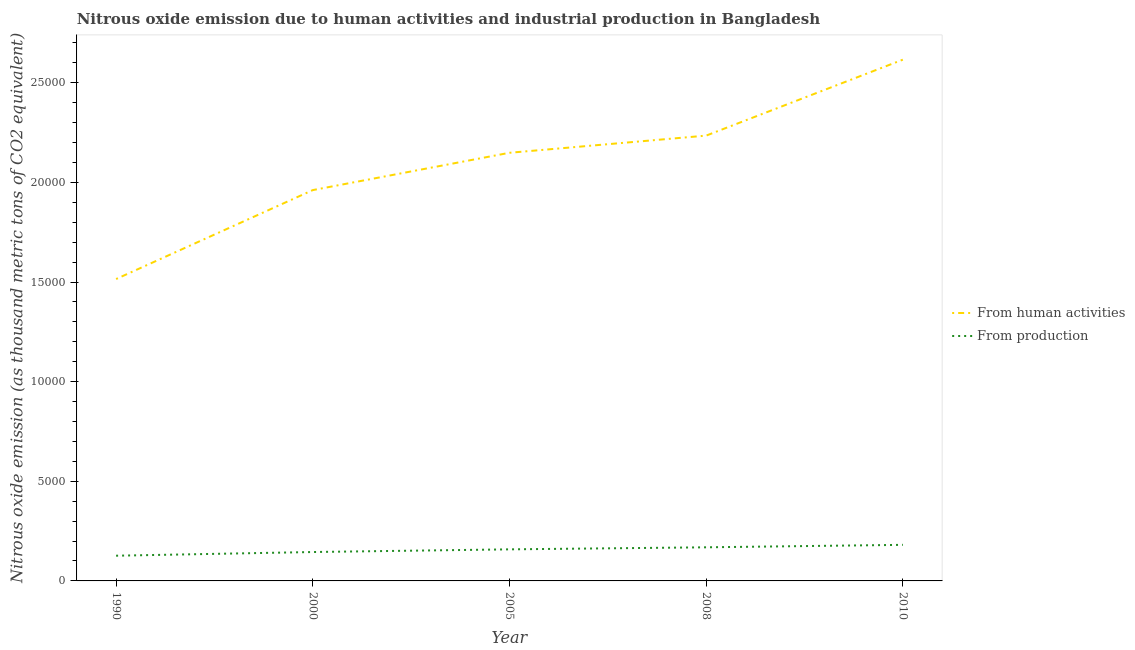Is the number of lines equal to the number of legend labels?
Provide a short and direct response. Yes. What is the amount of emissions from human activities in 2005?
Keep it short and to the point. 2.15e+04. Across all years, what is the maximum amount of emissions from human activities?
Your answer should be very brief. 2.62e+04. Across all years, what is the minimum amount of emissions generated from industries?
Offer a very short reply. 1265.7. In which year was the amount of emissions generated from industries maximum?
Provide a short and direct response. 2010. In which year was the amount of emissions generated from industries minimum?
Your answer should be compact. 1990. What is the total amount of emissions from human activities in the graph?
Offer a very short reply. 1.05e+05. What is the difference between the amount of emissions generated from industries in 2008 and that in 2010?
Your answer should be compact. -123.9. What is the difference between the amount of emissions generated from industries in 2008 and the amount of emissions from human activities in 2000?
Your answer should be compact. -1.79e+04. What is the average amount of emissions from human activities per year?
Your answer should be compact. 2.10e+04. In the year 2000, what is the difference between the amount of emissions from human activities and amount of emissions generated from industries?
Offer a very short reply. 1.82e+04. In how many years, is the amount of emissions generated from industries greater than 4000 thousand metric tons?
Your response must be concise. 0. What is the ratio of the amount of emissions generated from industries in 1990 to that in 2008?
Keep it short and to the point. 0.75. Is the amount of emissions generated from industries in 2000 less than that in 2010?
Provide a short and direct response. Yes. Is the difference between the amount of emissions from human activities in 2000 and 2008 greater than the difference between the amount of emissions generated from industries in 2000 and 2008?
Provide a short and direct response. No. What is the difference between the highest and the second highest amount of emissions from human activities?
Your response must be concise. 3811.2. What is the difference between the highest and the lowest amount of emissions generated from industries?
Provide a short and direct response. 545.1. Is the sum of the amount of emissions generated from industries in 1990 and 2010 greater than the maximum amount of emissions from human activities across all years?
Your response must be concise. No. Does the amount of emissions generated from industries monotonically increase over the years?
Your response must be concise. Yes. Is the amount of emissions from human activities strictly greater than the amount of emissions generated from industries over the years?
Your answer should be compact. Yes. Is the amount of emissions generated from industries strictly less than the amount of emissions from human activities over the years?
Offer a terse response. Yes. Does the graph contain grids?
Ensure brevity in your answer.  No. Where does the legend appear in the graph?
Keep it short and to the point. Center right. What is the title of the graph?
Your response must be concise. Nitrous oxide emission due to human activities and industrial production in Bangladesh. What is the label or title of the Y-axis?
Give a very brief answer. Nitrous oxide emission (as thousand metric tons of CO2 equivalent). What is the Nitrous oxide emission (as thousand metric tons of CO2 equivalent) of From human activities in 1990?
Provide a short and direct response. 1.52e+04. What is the Nitrous oxide emission (as thousand metric tons of CO2 equivalent) in From production in 1990?
Provide a short and direct response. 1265.7. What is the Nitrous oxide emission (as thousand metric tons of CO2 equivalent) in From human activities in 2000?
Provide a succinct answer. 1.96e+04. What is the Nitrous oxide emission (as thousand metric tons of CO2 equivalent) of From production in 2000?
Give a very brief answer. 1450.3. What is the Nitrous oxide emission (as thousand metric tons of CO2 equivalent) of From human activities in 2005?
Provide a succinct answer. 2.15e+04. What is the Nitrous oxide emission (as thousand metric tons of CO2 equivalent) in From production in 2005?
Offer a very short reply. 1584.6. What is the Nitrous oxide emission (as thousand metric tons of CO2 equivalent) in From human activities in 2008?
Your response must be concise. 2.23e+04. What is the Nitrous oxide emission (as thousand metric tons of CO2 equivalent) in From production in 2008?
Offer a terse response. 1686.9. What is the Nitrous oxide emission (as thousand metric tons of CO2 equivalent) in From human activities in 2010?
Give a very brief answer. 2.62e+04. What is the Nitrous oxide emission (as thousand metric tons of CO2 equivalent) of From production in 2010?
Make the answer very short. 1810.8. Across all years, what is the maximum Nitrous oxide emission (as thousand metric tons of CO2 equivalent) in From human activities?
Your response must be concise. 2.62e+04. Across all years, what is the maximum Nitrous oxide emission (as thousand metric tons of CO2 equivalent) in From production?
Your answer should be very brief. 1810.8. Across all years, what is the minimum Nitrous oxide emission (as thousand metric tons of CO2 equivalent) in From human activities?
Your answer should be compact. 1.52e+04. Across all years, what is the minimum Nitrous oxide emission (as thousand metric tons of CO2 equivalent) in From production?
Provide a short and direct response. 1265.7. What is the total Nitrous oxide emission (as thousand metric tons of CO2 equivalent) of From human activities in the graph?
Offer a terse response. 1.05e+05. What is the total Nitrous oxide emission (as thousand metric tons of CO2 equivalent) of From production in the graph?
Provide a succinct answer. 7798.3. What is the difference between the Nitrous oxide emission (as thousand metric tons of CO2 equivalent) in From human activities in 1990 and that in 2000?
Ensure brevity in your answer.  -4463.6. What is the difference between the Nitrous oxide emission (as thousand metric tons of CO2 equivalent) of From production in 1990 and that in 2000?
Make the answer very short. -184.6. What is the difference between the Nitrous oxide emission (as thousand metric tons of CO2 equivalent) of From human activities in 1990 and that in 2005?
Provide a short and direct response. -6336.1. What is the difference between the Nitrous oxide emission (as thousand metric tons of CO2 equivalent) of From production in 1990 and that in 2005?
Make the answer very short. -318.9. What is the difference between the Nitrous oxide emission (as thousand metric tons of CO2 equivalent) of From human activities in 1990 and that in 2008?
Offer a very short reply. -7197.8. What is the difference between the Nitrous oxide emission (as thousand metric tons of CO2 equivalent) in From production in 1990 and that in 2008?
Your answer should be compact. -421.2. What is the difference between the Nitrous oxide emission (as thousand metric tons of CO2 equivalent) in From human activities in 1990 and that in 2010?
Offer a terse response. -1.10e+04. What is the difference between the Nitrous oxide emission (as thousand metric tons of CO2 equivalent) in From production in 1990 and that in 2010?
Ensure brevity in your answer.  -545.1. What is the difference between the Nitrous oxide emission (as thousand metric tons of CO2 equivalent) of From human activities in 2000 and that in 2005?
Make the answer very short. -1872.5. What is the difference between the Nitrous oxide emission (as thousand metric tons of CO2 equivalent) in From production in 2000 and that in 2005?
Offer a very short reply. -134.3. What is the difference between the Nitrous oxide emission (as thousand metric tons of CO2 equivalent) in From human activities in 2000 and that in 2008?
Make the answer very short. -2734.2. What is the difference between the Nitrous oxide emission (as thousand metric tons of CO2 equivalent) of From production in 2000 and that in 2008?
Give a very brief answer. -236.6. What is the difference between the Nitrous oxide emission (as thousand metric tons of CO2 equivalent) of From human activities in 2000 and that in 2010?
Offer a very short reply. -6545.4. What is the difference between the Nitrous oxide emission (as thousand metric tons of CO2 equivalent) of From production in 2000 and that in 2010?
Your answer should be very brief. -360.5. What is the difference between the Nitrous oxide emission (as thousand metric tons of CO2 equivalent) of From human activities in 2005 and that in 2008?
Your response must be concise. -861.7. What is the difference between the Nitrous oxide emission (as thousand metric tons of CO2 equivalent) in From production in 2005 and that in 2008?
Give a very brief answer. -102.3. What is the difference between the Nitrous oxide emission (as thousand metric tons of CO2 equivalent) of From human activities in 2005 and that in 2010?
Provide a short and direct response. -4672.9. What is the difference between the Nitrous oxide emission (as thousand metric tons of CO2 equivalent) of From production in 2005 and that in 2010?
Make the answer very short. -226.2. What is the difference between the Nitrous oxide emission (as thousand metric tons of CO2 equivalent) in From human activities in 2008 and that in 2010?
Provide a short and direct response. -3811.2. What is the difference between the Nitrous oxide emission (as thousand metric tons of CO2 equivalent) in From production in 2008 and that in 2010?
Offer a terse response. -123.9. What is the difference between the Nitrous oxide emission (as thousand metric tons of CO2 equivalent) of From human activities in 1990 and the Nitrous oxide emission (as thousand metric tons of CO2 equivalent) of From production in 2000?
Keep it short and to the point. 1.37e+04. What is the difference between the Nitrous oxide emission (as thousand metric tons of CO2 equivalent) in From human activities in 1990 and the Nitrous oxide emission (as thousand metric tons of CO2 equivalent) in From production in 2005?
Your answer should be very brief. 1.36e+04. What is the difference between the Nitrous oxide emission (as thousand metric tons of CO2 equivalent) of From human activities in 1990 and the Nitrous oxide emission (as thousand metric tons of CO2 equivalent) of From production in 2008?
Provide a succinct answer. 1.35e+04. What is the difference between the Nitrous oxide emission (as thousand metric tons of CO2 equivalent) of From human activities in 1990 and the Nitrous oxide emission (as thousand metric tons of CO2 equivalent) of From production in 2010?
Offer a very short reply. 1.33e+04. What is the difference between the Nitrous oxide emission (as thousand metric tons of CO2 equivalent) of From human activities in 2000 and the Nitrous oxide emission (as thousand metric tons of CO2 equivalent) of From production in 2005?
Your response must be concise. 1.80e+04. What is the difference between the Nitrous oxide emission (as thousand metric tons of CO2 equivalent) of From human activities in 2000 and the Nitrous oxide emission (as thousand metric tons of CO2 equivalent) of From production in 2008?
Give a very brief answer. 1.79e+04. What is the difference between the Nitrous oxide emission (as thousand metric tons of CO2 equivalent) in From human activities in 2000 and the Nitrous oxide emission (as thousand metric tons of CO2 equivalent) in From production in 2010?
Give a very brief answer. 1.78e+04. What is the difference between the Nitrous oxide emission (as thousand metric tons of CO2 equivalent) in From human activities in 2005 and the Nitrous oxide emission (as thousand metric tons of CO2 equivalent) in From production in 2008?
Your answer should be very brief. 1.98e+04. What is the difference between the Nitrous oxide emission (as thousand metric tons of CO2 equivalent) of From human activities in 2005 and the Nitrous oxide emission (as thousand metric tons of CO2 equivalent) of From production in 2010?
Your response must be concise. 1.97e+04. What is the difference between the Nitrous oxide emission (as thousand metric tons of CO2 equivalent) of From human activities in 2008 and the Nitrous oxide emission (as thousand metric tons of CO2 equivalent) of From production in 2010?
Give a very brief answer. 2.05e+04. What is the average Nitrous oxide emission (as thousand metric tons of CO2 equivalent) in From human activities per year?
Keep it short and to the point. 2.10e+04. What is the average Nitrous oxide emission (as thousand metric tons of CO2 equivalent) of From production per year?
Offer a very short reply. 1559.66. In the year 1990, what is the difference between the Nitrous oxide emission (as thousand metric tons of CO2 equivalent) of From human activities and Nitrous oxide emission (as thousand metric tons of CO2 equivalent) of From production?
Your answer should be compact. 1.39e+04. In the year 2000, what is the difference between the Nitrous oxide emission (as thousand metric tons of CO2 equivalent) of From human activities and Nitrous oxide emission (as thousand metric tons of CO2 equivalent) of From production?
Your answer should be compact. 1.82e+04. In the year 2005, what is the difference between the Nitrous oxide emission (as thousand metric tons of CO2 equivalent) of From human activities and Nitrous oxide emission (as thousand metric tons of CO2 equivalent) of From production?
Offer a very short reply. 1.99e+04. In the year 2008, what is the difference between the Nitrous oxide emission (as thousand metric tons of CO2 equivalent) of From human activities and Nitrous oxide emission (as thousand metric tons of CO2 equivalent) of From production?
Your answer should be very brief. 2.07e+04. In the year 2010, what is the difference between the Nitrous oxide emission (as thousand metric tons of CO2 equivalent) of From human activities and Nitrous oxide emission (as thousand metric tons of CO2 equivalent) of From production?
Provide a short and direct response. 2.43e+04. What is the ratio of the Nitrous oxide emission (as thousand metric tons of CO2 equivalent) in From human activities in 1990 to that in 2000?
Give a very brief answer. 0.77. What is the ratio of the Nitrous oxide emission (as thousand metric tons of CO2 equivalent) in From production in 1990 to that in 2000?
Your answer should be very brief. 0.87. What is the ratio of the Nitrous oxide emission (as thousand metric tons of CO2 equivalent) in From human activities in 1990 to that in 2005?
Give a very brief answer. 0.71. What is the ratio of the Nitrous oxide emission (as thousand metric tons of CO2 equivalent) of From production in 1990 to that in 2005?
Keep it short and to the point. 0.8. What is the ratio of the Nitrous oxide emission (as thousand metric tons of CO2 equivalent) of From human activities in 1990 to that in 2008?
Your answer should be very brief. 0.68. What is the ratio of the Nitrous oxide emission (as thousand metric tons of CO2 equivalent) of From production in 1990 to that in 2008?
Your answer should be very brief. 0.75. What is the ratio of the Nitrous oxide emission (as thousand metric tons of CO2 equivalent) in From human activities in 1990 to that in 2010?
Give a very brief answer. 0.58. What is the ratio of the Nitrous oxide emission (as thousand metric tons of CO2 equivalent) in From production in 1990 to that in 2010?
Keep it short and to the point. 0.7. What is the ratio of the Nitrous oxide emission (as thousand metric tons of CO2 equivalent) in From human activities in 2000 to that in 2005?
Provide a succinct answer. 0.91. What is the ratio of the Nitrous oxide emission (as thousand metric tons of CO2 equivalent) in From production in 2000 to that in 2005?
Your answer should be compact. 0.92. What is the ratio of the Nitrous oxide emission (as thousand metric tons of CO2 equivalent) of From human activities in 2000 to that in 2008?
Your response must be concise. 0.88. What is the ratio of the Nitrous oxide emission (as thousand metric tons of CO2 equivalent) of From production in 2000 to that in 2008?
Give a very brief answer. 0.86. What is the ratio of the Nitrous oxide emission (as thousand metric tons of CO2 equivalent) of From human activities in 2000 to that in 2010?
Your answer should be compact. 0.75. What is the ratio of the Nitrous oxide emission (as thousand metric tons of CO2 equivalent) in From production in 2000 to that in 2010?
Keep it short and to the point. 0.8. What is the ratio of the Nitrous oxide emission (as thousand metric tons of CO2 equivalent) of From human activities in 2005 to that in 2008?
Offer a terse response. 0.96. What is the ratio of the Nitrous oxide emission (as thousand metric tons of CO2 equivalent) of From production in 2005 to that in 2008?
Offer a terse response. 0.94. What is the ratio of the Nitrous oxide emission (as thousand metric tons of CO2 equivalent) in From human activities in 2005 to that in 2010?
Ensure brevity in your answer.  0.82. What is the ratio of the Nitrous oxide emission (as thousand metric tons of CO2 equivalent) in From production in 2005 to that in 2010?
Offer a terse response. 0.88. What is the ratio of the Nitrous oxide emission (as thousand metric tons of CO2 equivalent) of From human activities in 2008 to that in 2010?
Offer a very short reply. 0.85. What is the ratio of the Nitrous oxide emission (as thousand metric tons of CO2 equivalent) in From production in 2008 to that in 2010?
Ensure brevity in your answer.  0.93. What is the difference between the highest and the second highest Nitrous oxide emission (as thousand metric tons of CO2 equivalent) of From human activities?
Offer a very short reply. 3811.2. What is the difference between the highest and the second highest Nitrous oxide emission (as thousand metric tons of CO2 equivalent) of From production?
Offer a very short reply. 123.9. What is the difference between the highest and the lowest Nitrous oxide emission (as thousand metric tons of CO2 equivalent) in From human activities?
Offer a very short reply. 1.10e+04. What is the difference between the highest and the lowest Nitrous oxide emission (as thousand metric tons of CO2 equivalent) of From production?
Offer a terse response. 545.1. 